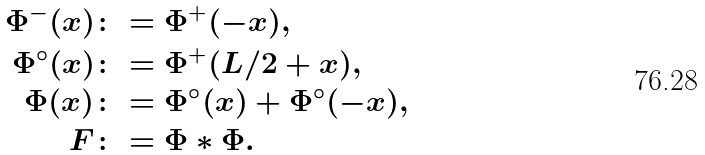Convert formula to latex. <formula><loc_0><loc_0><loc_500><loc_500>\Phi ^ { - } ( x ) & \colon = \Phi ^ { + } ( - x ) , \\ \Phi ^ { \circ } ( x ) & \colon = \Phi ^ { + } ( L / 2 + x ) , \\ \Phi ( x ) & \colon = \Phi ^ { \circ } ( x ) + \Phi ^ { \circ } ( - x ) , \\ F & \colon = \Phi \ast \Phi .</formula> 